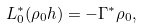<formula> <loc_0><loc_0><loc_500><loc_500>L _ { 0 } ^ { * } ( \rho _ { 0 } h ) = - \Gamma ^ { * } \rho _ { 0 } ,</formula> 